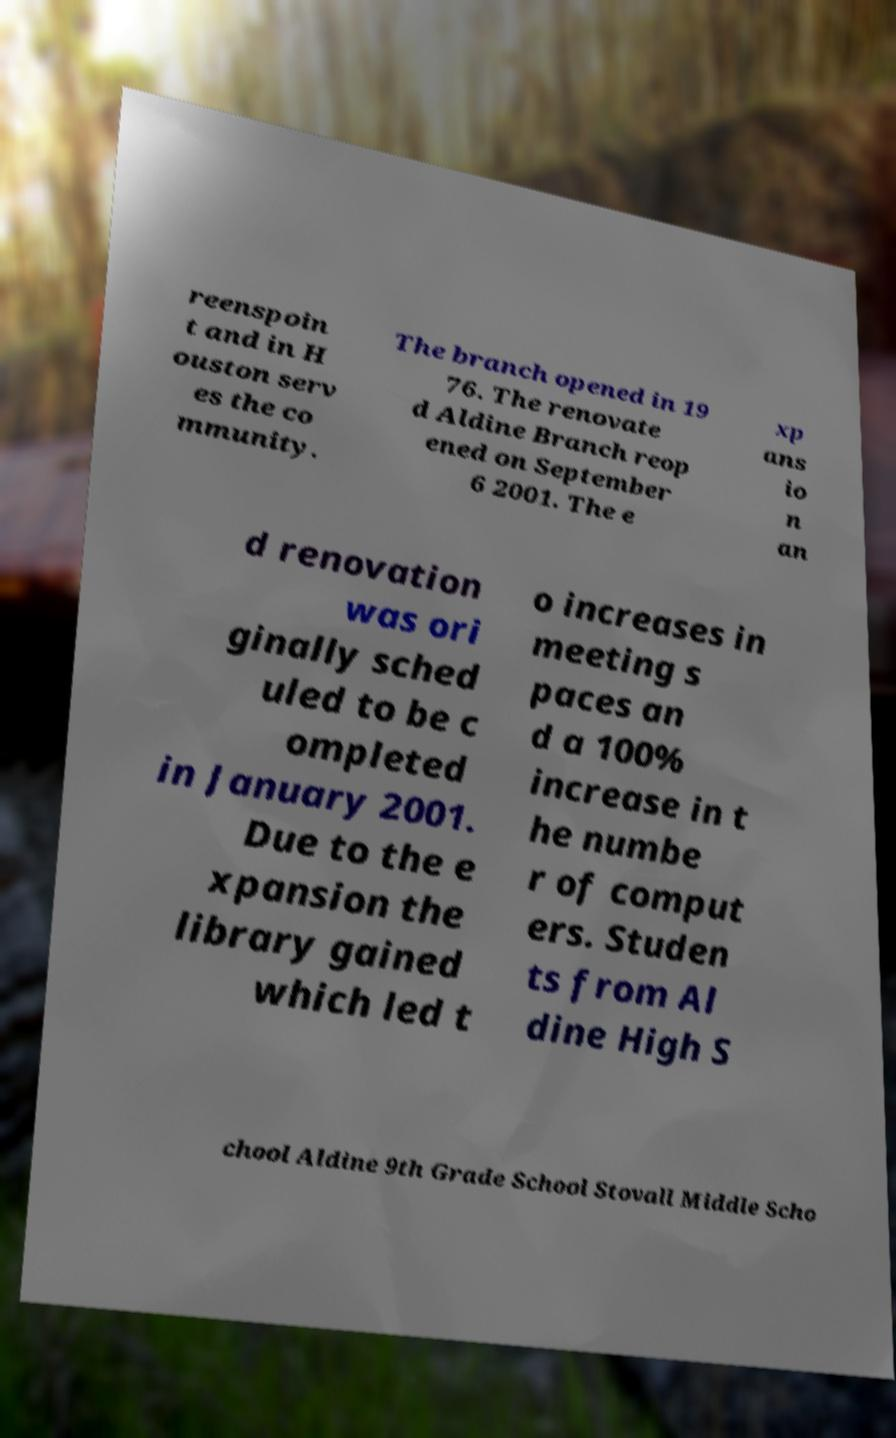Please read and relay the text visible in this image. What does it say? reenspoin t and in H ouston serv es the co mmunity. The branch opened in 19 76. The renovate d Aldine Branch reop ened on September 6 2001. The e xp ans io n an d renovation was ori ginally sched uled to be c ompleted in January 2001. Due to the e xpansion the library gained which led t o increases in meeting s paces an d a 100% increase in t he numbe r of comput ers. Studen ts from Al dine High S chool Aldine 9th Grade School Stovall Middle Scho 